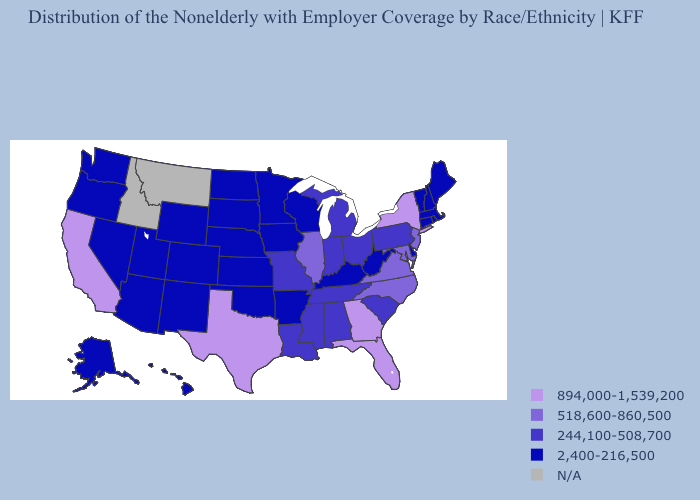Name the states that have a value in the range 894,000-1,539,200?
Give a very brief answer. California, Florida, Georgia, New York, Texas. Among the states that border Oregon , does California have the lowest value?
Be succinct. No. Does the map have missing data?
Write a very short answer. Yes. Name the states that have a value in the range 2,400-216,500?
Write a very short answer. Alaska, Arizona, Arkansas, Colorado, Connecticut, Delaware, Hawaii, Iowa, Kansas, Kentucky, Maine, Massachusetts, Minnesota, Nebraska, Nevada, New Hampshire, New Mexico, North Dakota, Oklahoma, Oregon, Rhode Island, South Dakota, Utah, Vermont, Washington, West Virginia, Wisconsin, Wyoming. Does the first symbol in the legend represent the smallest category?
Give a very brief answer. No. What is the value of New Hampshire?
Write a very short answer. 2,400-216,500. Name the states that have a value in the range 244,100-508,700?
Answer briefly. Alabama, Indiana, Louisiana, Michigan, Mississippi, Missouri, Ohio, Pennsylvania, South Carolina, Tennessee. What is the highest value in states that border South Carolina?
Give a very brief answer. 894,000-1,539,200. Among the states that border Wisconsin , which have the highest value?
Be succinct. Illinois. Name the states that have a value in the range 518,600-860,500?
Keep it brief. Illinois, Maryland, New Jersey, North Carolina, Virginia. What is the value of Colorado?
Write a very short answer. 2,400-216,500. What is the lowest value in the West?
Quick response, please. 2,400-216,500. What is the value of Massachusetts?
Keep it brief. 2,400-216,500. What is the highest value in the Northeast ?
Concise answer only. 894,000-1,539,200. 